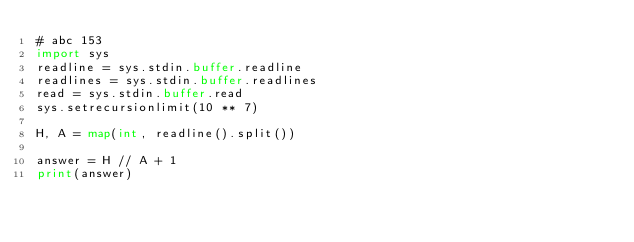Convert code to text. <code><loc_0><loc_0><loc_500><loc_500><_Python_># abc 153
import sys
readline = sys.stdin.buffer.readline
readlines = sys.stdin.buffer.readlines
read = sys.stdin.buffer.read
sys.setrecursionlimit(10 ** 7)

H, A = map(int, readline().split())

answer = H // A + 1
print(answer)</code> 